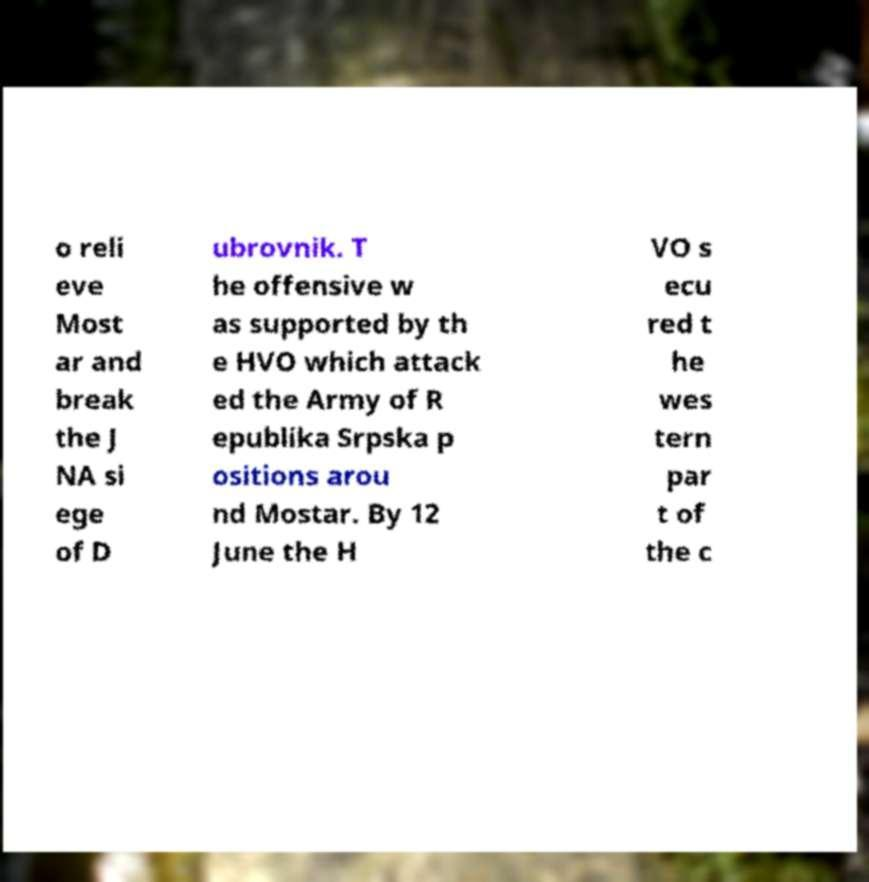Please read and relay the text visible in this image. What does it say? o reli eve Most ar and break the J NA si ege of D ubrovnik. T he offensive w as supported by th e HVO which attack ed the Army of R epublika Srpska p ositions arou nd Mostar. By 12 June the H VO s ecu red t he wes tern par t of the c 